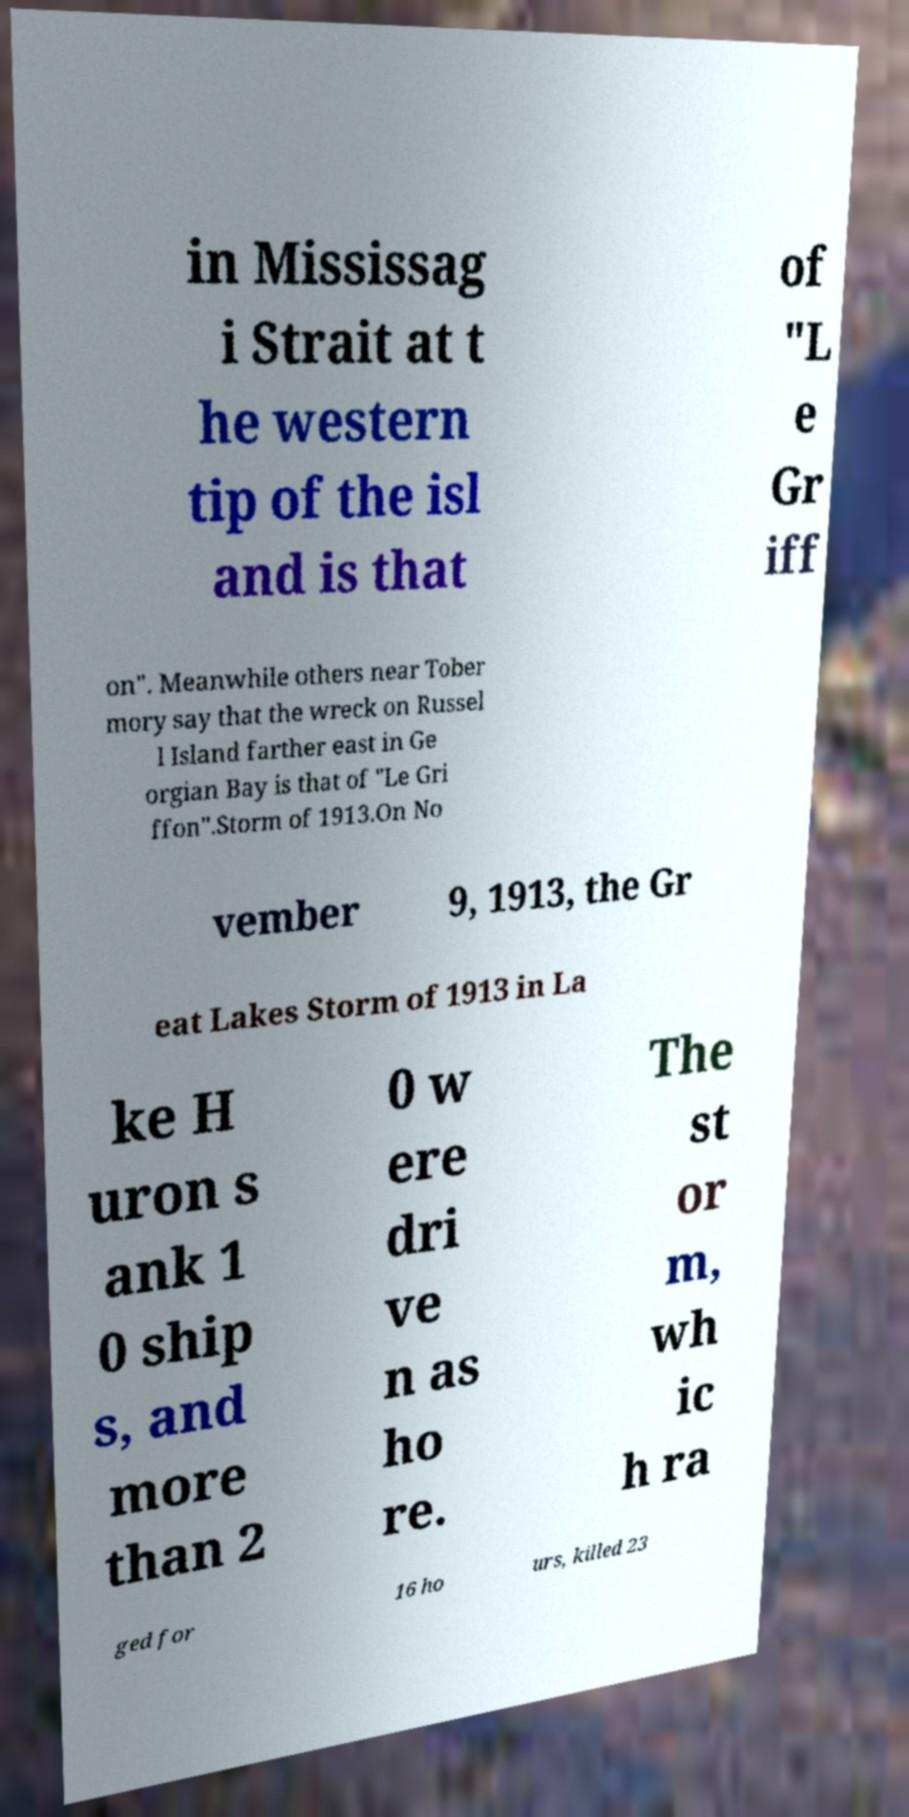Could you assist in decoding the text presented in this image and type it out clearly? in Mississag i Strait at t he western tip of the isl and is that of "L e Gr iff on". Meanwhile others near Tober mory say that the wreck on Russel l Island farther east in Ge orgian Bay is that of "Le Gri ffon".Storm of 1913.On No vember 9, 1913, the Gr eat Lakes Storm of 1913 in La ke H uron s ank 1 0 ship s, and more than 2 0 w ere dri ve n as ho re. The st or m, wh ic h ra ged for 16 ho urs, killed 23 